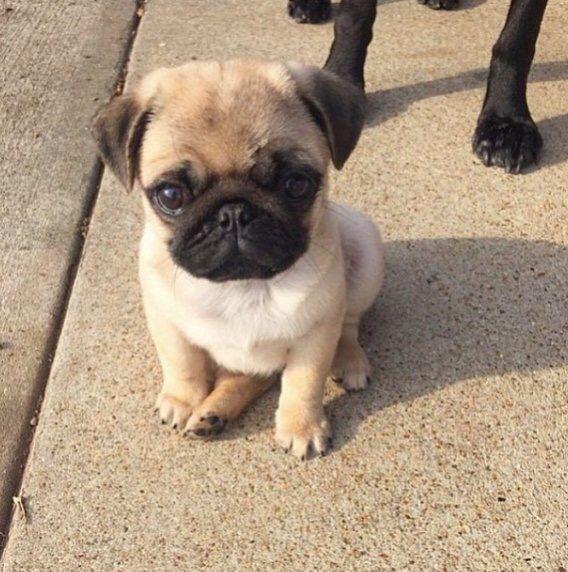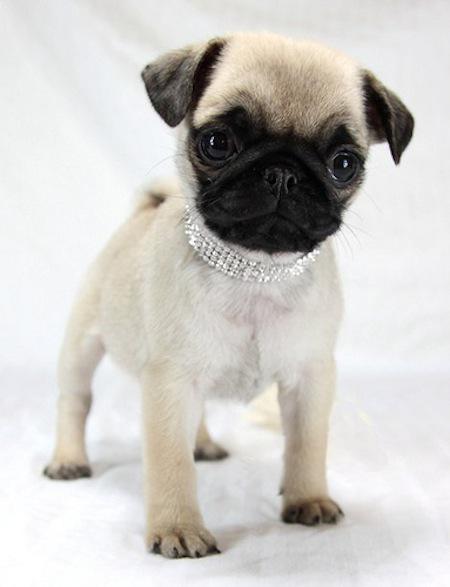The first image is the image on the left, the second image is the image on the right. Considering the images on both sides, is "Each image contains exactly one small pug puppy, and the puppy on the left is in a sitting pose with its front paws on the ground." valid? Answer yes or no. Yes. The first image is the image on the left, the second image is the image on the right. Assess this claim about the two images: "The dog in the image on the left is on a pink piece of material.". Correct or not? Answer yes or no. No. 